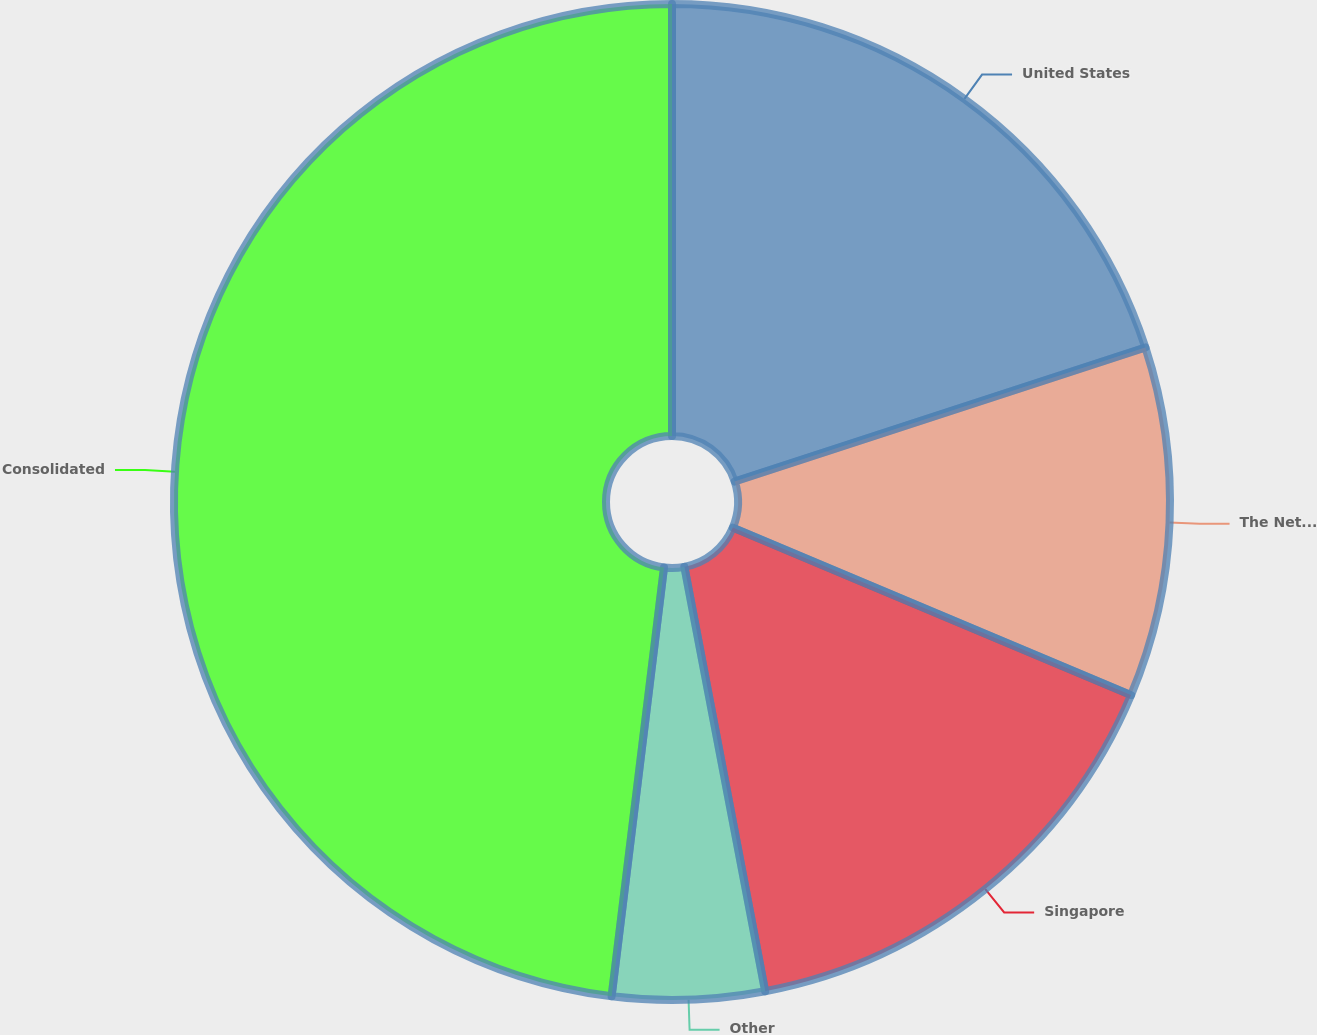<chart> <loc_0><loc_0><loc_500><loc_500><pie_chart><fcel>United States<fcel>The Netherlands<fcel>Singapore<fcel>Other<fcel>Consolidated<nl><fcel>19.98%<fcel>11.36%<fcel>15.67%<fcel>4.93%<fcel>48.07%<nl></chart> 